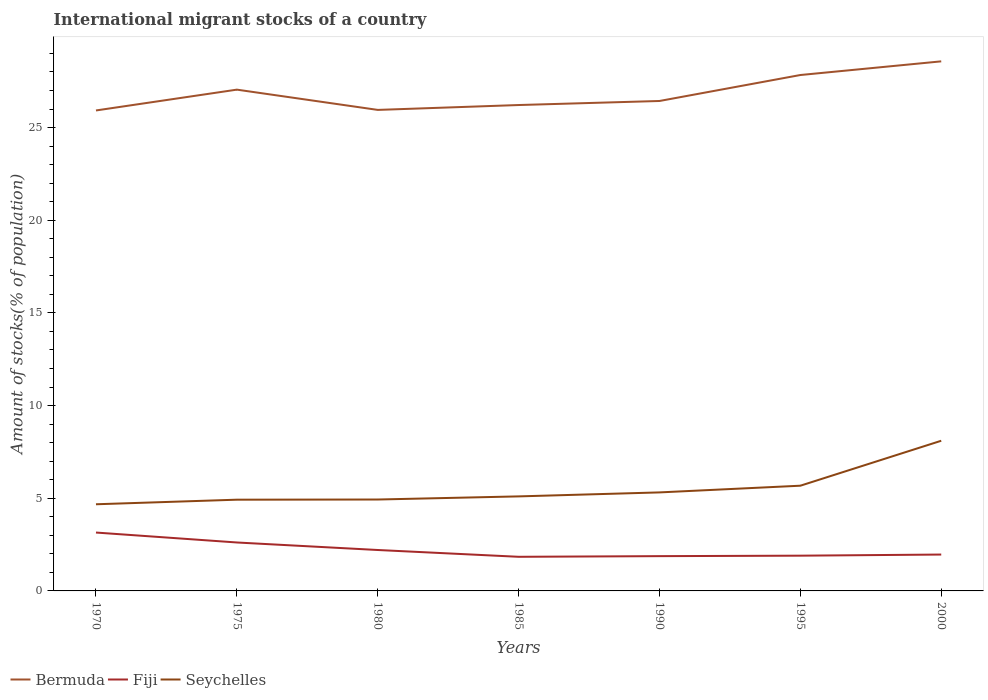How many different coloured lines are there?
Make the answer very short. 3. Is the number of lines equal to the number of legend labels?
Make the answer very short. Yes. Across all years, what is the maximum amount of stocks in in Bermuda?
Offer a very short reply. 25.92. In which year was the amount of stocks in in Fiji maximum?
Keep it short and to the point. 1985. What is the total amount of stocks in in Fiji in the graph?
Your answer should be very brief. 0.37. What is the difference between the highest and the second highest amount of stocks in in Seychelles?
Offer a terse response. 3.43. What is the difference between the highest and the lowest amount of stocks in in Seychelles?
Give a very brief answer. 2. How many years are there in the graph?
Make the answer very short. 7. What is the difference between two consecutive major ticks on the Y-axis?
Provide a short and direct response. 5. Where does the legend appear in the graph?
Your answer should be compact. Bottom left. What is the title of the graph?
Offer a very short reply. International migrant stocks of a country. Does "Latvia" appear as one of the legend labels in the graph?
Offer a very short reply. No. What is the label or title of the X-axis?
Give a very brief answer. Years. What is the label or title of the Y-axis?
Give a very brief answer. Amount of stocks(% of population). What is the Amount of stocks(% of population) in Bermuda in 1970?
Your answer should be very brief. 25.92. What is the Amount of stocks(% of population) of Fiji in 1970?
Offer a very short reply. 3.15. What is the Amount of stocks(% of population) of Seychelles in 1970?
Your answer should be compact. 4.68. What is the Amount of stocks(% of population) in Bermuda in 1975?
Your answer should be compact. 27.05. What is the Amount of stocks(% of population) in Fiji in 1975?
Offer a very short reply. 2.61. What is the Amount of stocks(% of population) in Seychelles in 1975?
Offer a very short reply. 4.92. What is the Amount of stocks(% of population) of Bermuda in 1980?
Make the answer very short. 25.95. What is the Amount of stocks(% of population) of Fiji in 1980?
Provide a succinct answer. 2.21. What is the Amount of stocks(% of population) in Seychelles in 1980?
Provide a succinct answer. 4.93. What is the Amount of stocks(% of population) in Bermuda in 1985?
Make the answer very short. 26.22. What is the Amount of stocks(% of population) of Fiji in 1985?
Provide a short and direct response. 1.84. What is the Amount of stocks(% of population) in Seychelles in 1985?
Your answer should be very brief. 5.1. What is the Amount of stocks(% of population) in Bermuda in 1990?
Offer a terse response. 26.44. What is the Amount of stocks(% of population) of Fiji in 1990?
Your response must be concise. 1.88. What is the Amount of stocks(% of population) in Seychelles in 1990?
Your answer should be compact. 5.32. What is the Amount of stocks(% of population) of Bermuda in 1995?
Offer a very short reply. 27.84. What is the Amount of stocks(% of population) in Fiji in 1995?
Provide a succinct answer. 1.9. What is the Amount of stocks(% of population) of Seychelles in 1995?
Provide a short and direct response. 5.68. What is the Amount of stocks(% of population) in Bermuda in 2000?
Provide a short and direct response. 28.57. What is the Amount of stocks(% of population) of Fiji in 2000?
Your answer should be compact. 1.96. What is the Amount of stocks(% of population) of Seychelles in 2000?
Ensure brevity in your answer.  8.1. Across all years, what is the maximum Amount of stocks(% of population) in Bermuda?
Offer a terse response. 28.57. Across all years, what is the maximum Amount of stocks(% of population) in Fiji?
Your response must be concise. 3.15. Across all years, what is the maximum Amount of stocks(% of population) of Seychelles?
Your answer should be very brief. 8.1. Across all years, what is the minimum Amount of stocks(% of population) in Bermuda?
Provide a short and direct response. 25.92. Across all years, what is the minimum Amount of stocks(% of population) of Fiji?
Ensure brevity in your answer.  1.84. Across all years, what is the minimum Amount of stocks(% of population) in Seychelles?
Make the answer very short. 4.68. What is the total Amount of stocks(% of population) of Bermuda in the graph?
Keep it short and to the point. 187.99. What is the total Amount of stocks(% of population) in Fiji in the graph?
Give a very brief answer. 15.55. What is the total Amount of stocks(% of population) in Seychelles in the graph?
Your response must be concise. 38.73. What is the difference between the Amount of stocks(% of population) of Bermuda in 1970 and that in 1975?
Keep it short and to the point. -1.12. What is the difference between the Amount of stocks(% of population) of Fiji in 1970 and that in 1975?
Keep it short and to the point. 0.54. What is the difference between the Amount of stocks(% of population) of Seychelles in 1970 and that in 1975?
Keep it short and to the point. -0.25. What is the difference between the Amount of stocks(% of population) in Bermuda in 1970 and that in 1980?
Keep it short and to the point. -0.03. What is the difference between the Amount of stocks(% of population) in Fiji in 1970 and that in 1980?
Provide a short and direct response. 0.94. What is the difference between the Amount of stocks(% of population) in Seychelles in 1970 and that in 1980?
Ensure brevity in your answer.  -0.26. What is the difference between the Amount of stocks(% of population) in Bermuda in 1970 and that in 1985?
Give a very brief answer. -0.29. What is the difference between the Amount of stocks(% of population) in Fiji in 1970 and that in 1985?
Provide a short and direct response. 1.31. What is the difference between the Amount of stocks(% of population) in Seychelles in 1970 and that in 1985?
Give a very brief answer. -0.43. What is the difference between the Amount of stocks(% of population) of Bermuda in 1970 and that in 1990?
Offer a terse response. -0.51. What is the difference between the Amount of stocks(% of population) of Fiji in 1970 and that in 1990?
Make the answer very short. 1.27. What is the difference between the Amount of stocks(% of population) in Seychelles in 1970 and that in 1990?
Your answer should be very brief. -0.64. What is the difference between the Amount of stocks(% of population) of Bermuda in 1970 and that in 1995?
Your answer should be compact. -1.91. What is the difference between the Amount of stocks(% of population) of Fiji in 1970 and that in 1995?
Offer a terse response. 1.25. What is the difference between the Amount of stocks(% of population) in Seychelles in 1970 and that in 1995?
Make the answer very short. -1. What is the difference between the Amount of stocks(% of population) of Bermuda in 1970 and that in 2000?
Keep it short and to the point. -2.65. What is the difference between the Amount of stocks(% of population) in Fiji in 1970 and that in 2000?
Your answer should be compact. 1.19. What is the difference between the Amount of stocks(% of population) of Seychelles in 1970 and that in 2000?
Keep it short and to the point. -3.43. What is the difference between the Amount of stocks(% of population) in Bermuda in 1975 and that in 1980?
Keep it short and to the point. 1.09. What is the difference between the Amount of stocks(% of population) in Fiji in 1975 and that in 1980?
Provide a succinct answer. 0.41. What is the difference between the Amount of stocks(% of population) of Seychelles in 1975 and that in 1980?
Your answer should be very brief. -0.01. What is the difference between the Amount of stocks(% of population) of Bermuda in 1975 and that in 1985?
Ensure brevity in your answer.  0.83. What is the difference between the Amount of stocks(% of population) in Fiji in 1975 and that in 1985?
Give a very brief answer. 0.77. What is the difference between the Amount of stocks(% of population) of Seychelles in 1975 and that in 1985?
Your response must be concise. -0.18. What is the difference between the Amount of stocks(% of population) in Bermuda in 1975 and that in 1990?
Offer a very short reply. 0.61. What is the difference between the Amount of stocks(% of population) in Fiji in 1975 and that in 1990?
Provide a succinct answer. 0.74. What is the difference between the Amount of stocks(% of population) of Seychelles in 1975 and that in 1990?
Ensure brevity in your answer.  -0.39. What is the difference between the Amount of stocks(% of population) of Bermuda in 1975 and that in 1995?
Your answer should be compact. -0.79. What is the difference between the Amount of stocks(% of population) of Fiji in 1975 and that in 1995?
Your response must be concise. 0.71. What is the difference between the Amount of stocks(% of population) in Seychelles in 1975 and that in 1995?
Offer a very short reply. -0.75. What is the difference between the Amount of stocks(% of population) of Bermuda in 1975 and that in 2000?
Ensure brevity in your answer.  -1.53. What is the difference between the Amount of stocks(% of population) in Fiji in 1975 and that in 2000?
Ensure brevity in your answer.  0.65. What is the difference between the Amount of stocks(% of population) in Seychelles in 1975 and that in 2000?
Keep it short and to the point. -3.18. What is the difference between the Amount of stocks(% of population) of Bermuda in 1980 and that in 1985?
Your answer should be compact. -0.26. What is the difference between the Amount of stocks(% of population) of Fiji in 1980 and that in 1985?
Give a very brief answer. 0.37. What is the difference between the Amount of stocks(% of population) of Seychelles in 1980 and that in 1985?
Give a very brief answer. -0.17. What is the difference between the Amount of stocks(% of population) of Bermuda in 1980 and that in 1990?
Your response must be concise. -0.48. What is the difference between the Amount of stocks(% of population) in Fiji in 1980 and that in 1990?
Offer a terse response. 0.33. What is the difference between the Amount of stocks(% of population) in Seychelles in 1980 and that in 1990?
Ensure brevity in your answer.  -0.38. What is the difference between the Amount of stocks(% of population) of Bermuda in 1980 and that in 1995?
Provide a short and direct response. -1.88. What is the difference between the Amount of stocks(% of population) in Fiji in 1980 and that in 1995?
Provide a short and direct response. 0.31. What is the difference between the Amount of stocks(% of population) of Seychelles in 1980 and that in 1995?
Offer a terse response. -0.75. What is the difference between the Amount of stocks(% of population) in Bermuda in 1980 and that in 2000?
Your response must be concise. -2.62. What is the difference between the Amount of stocks(% of population) in Fiji in 1980 and that in 2000?
Keep it short and to the point. 0.25. What is the difference between the Amount of stocks(% of population) of Seychelles in 1980 and that in 2000?
Ensure brevity in your answer.  -3.17. What is the difference between the Amount of stocks(% of population) in Bermuda in 1985 and that in 1990?
Make the answer very short. -0.22. What is the difference between the Amount of stocks(% of population) of Fiji in 1985 and that in 1990?
Give a very brief answer. -0.04. What is the difference between the Amount of stocks(% of population) in Seychelles in 1985 and that in 1990?
Ensure brevity in your answer.  -0.21. What is the difference between the Amount of stocks(% of population) of Bermuda in 1985 and that in 1995?
Provide a succinct answer. -1.62. What is the difference between the Amount of stocks(% of population) in Fiji in 1985 and that in 1995?
Provide a short and direct response. -0.06. What is the difference between the Amount of stocks(% of population) of Seychelles in 1985 and that in 1995?
Keep it short and to the point. -0.58. What is the difference between the Amount of stocks(% of population) in Bermuda in 1985 and that in 2000?
Provide a succinct answer. -2.36. What is the difference between the Amount of stocks(% of population) in Fiji in 1985 and that in 2000?
Offer a terse response. -0.12. What is the difference between the Amount of stocks(% of population) in Seychelles in 1985 and that in 2000?
Your answer should be very brief. -3. What is the difference between the Amount of stocks(% of population) in Bermuda in 1990 and that in 1995?
Your answer should be very brief. -1.4. What is the difference between the Amount of stocks(% of population) of Fiji in 1990 and that in 1995?
Ensure brevity in your answer.  -0.03. What is the difference between the Amount of stocks(% of population) in Seychelles in 1990 and that in 1995?
Make the answer very short. -0.36. What is the difference between the Amount of stocks(% of population) in Bermuda in 1990 and that in 2000?
Keep it short and to the point. -2.14. What is the difference between the Amount of stocks(% of population) in Fiji in 1990 and that in 2000?
Keep it short and to the point. -0.09. What is the difference between the Amount of stocks(% of population) of Seychelles in 1990 and that in 2000?
Your response must be concise. -2.79. What is the difference between the Amount of stocks(% of population) of Bermuda in 1995 and that in 2000?
Give a very brief answer. -0.74. What is the difference between the Amount of stocks(% of population) in Fiji in 1995 and that in 2000?
Make the answer very short. -0.06. What is the difference between the Amount of stocks(% of population) of Seychelles in 1995 and that in 2000?
Keep it short and to the point. -2.43. What is the difference between the Amount of stocks(% of population) of Bermuda in 1970 and the Amount of stocks(% of population) of Fiji in 1975?
Provide a succinct answer. 23.31. What is the difference between the Amount of stocks(% of population) in Bermuda in 1970 and the Amount of stocks(% of population) in Seychelles in 1975?
Provide a succinct answer. 21. What is the difference between the Amount of stocks(% of population) in Fiji in 1970 and the Amount of stocks(% of population) in Seychelles in 1975?
Offer a terse response. -1.77. What is the difference between the Amount of stocks(% of population) in Bermuda in 1970 and the Amount of stocks(% of population) in Fiji in 1980?
Offer a very short reply. 23.72. What is the difference between the Amount of stocks(% of population) of Bermuda in 1970 and the Amount of stocks(% of population) of Seychelles in 1980?
Your response must be concise. 20.99. What is the difference between the Amount of stocks(% of population) of Fiji in 1970 and the Amount of stocks(% of population) of Seychelles in 1980?
Your answer should be very brief. -1.78. What is the difference between the Amount of stocks(% of population) of Bermuda in 1970 and the Amount of stocks(% of population) of Fiji in 1985?
Your answer should be compact. 24.08. What is the difference between the Amount of stocks(% of population) of Bermuda in 1970 and the Amount of stocks(% of population) of Seychelles in 1985?
Make the answer very short. 20.82. What is the difference between the Amount of stocks(% of population) in Fiji in 1970 and the Amount of stocks(% of population) in Seychelles in 1985?
Provide a succinct answer. -1.95. What is the difference between the Amount of stocks(% of population) of Bermuda in 1970 and the Amount of stocks(% of population) of Fiji in 1990?
Keep it short and to the point. 24.05. What is the difference between the Amount of stocks(% of population) in Bermuda in 1970 and the Amount of stocks(% of population) in Seychelles in 1990?
Your answer should be very brief. 20.61. What is the difference between the Amount of stocks(% of population) in Fiji in 1970 and the Amount of stocks(% of population) in Seychelles in 1990?
Make the answer very short. -2.17. What is the difference between the Amount of stocks(% of population) in Bermuda in 1970 and the Amount of stocks(% of population) in Fiji in 1995?
Offer a terse response. 24.02. What is the difference between the Amount of stocks(% of population) in Bermuda in 1970 and the Amount of stocks(% of population) in Seychelles in 1995?
Offer a terse response. 20.25. What is the difference between the Amount of stocks(% of population) in Fiji in 1970 and the Amount of stocks(% of population) in Seychelles in 1995?
Provide a short and direct response. -2.53. What is the difference between the Amount of stocks(% of population) of Bermuda in 1970 and the Amount of stocks(% of population) of Fiji in 2000?
Offer a very short reply. 23.96. What is the difference between the Amount of stocks(% of population) in Bermuda in 1970 and the Amount of stocks(% of population) in Seychelles in 2000?
Your answer should be compact. 17.82. What is the difference between the Amount of stocks(% of population) of Fiji in 1970 and the Amount of stocks(% of population) of Seychelles in 2000?
Ensure brevity in your answer.  -4.95. What is the difference between the Amount of stocks(% of population) of Bermuda in 1975 and the Amount of stocks(% of population) of Fiji in 1980?
Your answer should be compact. 24.84. What is the difference between the Amount of stocks(% of population) of Bermuda in 1975 and the Amount of stocks(% of population) of Seychelles in 1980?
Ensure brevity in your answer.  22.12. What is the difference between the Amount of stocks(% of population) in Fiji in 1975 and the Amount of stocks(% of population) in Seychelles in 1980?
Your answer should be very brief. -2.32. What is the difference between the Amount of stocks(% of population) in Bermuda in 1975 and the Amount of stocks(% of population) in Fiji in 1985?
Provide a short and direct response. 25.21. What is the difference between the Amount of stocks(% of population) in Bermuda in 1975 and the Amount of stocks(% of population) in Seychelles in 1985?
Offer a very short reply. 21.95. What is the difference between the Amount of stocks(% of population) of Fiji in 1975 and the Amount of stocks(% of population) of Seychelles in 1985?
Your response must be concise. -2.49. What is the difference between the Amount of stocks(% of population) in Bermuda in 1975 and the Amount of stocks(% of population) in Fiji in 1990?
Provide a succinct answer. 25.17. What is the difference between the Amount of stocks(% of population) in Bermuda in 1975 and the Amount of stocks(% of population) in Seychelles in 1990?
Offer a very short reply. 21.73. What is the difference between the Amount of stocks(% of population) in Fiji in 1975 and the Amount of stocks(% of population) in Seychelles in 1990?
Provide a succinct answer. -2.7. What is the difference between the Amount of stocks(% of population) of Bermuda in 1975 and the Amount of stocks(% of population) of Fiji in 1995?
Your answer should be compact. 25.14. What is the difference between the Amount of stocks(% of population) in Bermuda in 1975 and the Amount of stocks(% of population) in Seychelles in 1995?
Your answer should be compact. 21.37. What is the difference between the Amount of stocks(% of population) of Fiji in 1975 and the Amount of stocks(% of population) of Seychelles in 1995?
Offer a very short reply. -3.06. What is the difference between the Amount of stocks(% of population) of Bermuda in 1975 and the Amount of stocks(% of population) of Fiji in 2000?
Offer a very short reply. 25.08. What is the difference between the Amount of stocks(% of population) of Bermuda in 1975 and the Amount of stocks(% of population) of Seychelles in 2000?
Give a very brief answer. 18.94. What is the difference between the Amount of stocks(% of population) of Fiji in 1975 and the Amount of stocks(% of population) of Seychelles in 2000?
Make the answer very short. -5.49. What is the difference between the Amount of stocks(% of population) of Bermuda in 1980 and the Amount of stocks(% of population) of Fiji in 1985?
Provide a succinct answer. 24.11. What is the difference between the Amount of stocks(% of population) in Bermuda in 1980 and the Amount of stocks(% of population) in Seychelles in 1985?
Ensure brevity in your answer.  20.85. What is the difference between the Amount of stocks(% of population) in Fiji in 1980 and the Amount of stocks(% of population) in Seychelles in 1985?
Offer a terse response. -2.89. What is the difference between the Amount of stocks(% of population) in Bermuda in 1980 and the Amount of stocks(% of population) in Fiji in 1990?
Provide a short and direct response. 24.08. What is the difference between the Amount of stocks(% of population) of Bermuda in 1980 and the Amount of stocks(% of population) of Seychelles in 1990?
Keep it short and to the point. 20.64. What is the difference between the Amount of stocks(% of population) in Fiji in 1980 and the Amount of stocks(% of population) in Seychelles in 1990?
Offer a very short reply. -3.11. What is the difference between the Amount of stocks(% of population) of Bermuda in 1980 and the Amount of stocks(% of population) of Fiji in 1995?
Your answer should be very brief. 24.05. What is the difference between the Amount of stocks(% of population) in Bermuda in 1980 and the Amount of stocks(% of population) in Seychelles in 1995?
Your answer should be very brief. 20.28. What is the difference between the Amount of stocks(% of population) in Fiji in 1980 and the Amount of stocks(% of population) in Seychelles in 1995?
Offer a terse response. -3.47. What is the difference between the Amount of stocks(% of population) in Bermuda in 1980 and the Amount of stocks(% of population) in Fiji in 2000?
Your answer should be very brief. 23.99. What is the difference between the Amount of stocks(% of population) of Bermuda in 1980 and the Amount of stocks(% of population) of Seychelles in 2000?
Keep it short and to the point. 17.85. What is the difference between the Amount of stocks(% of population) in Fiji in 1980 and the Amount of stocks(% of population) in Seychelles in 2000?
Your answer should be compact. -5.9. What is the difference between the Amount of stocks(% of population) of Bermuda in 1985 and the Amount of stocks(% of population) of Fiji in 1990?
Your answer should be compact. 24.34. What is the difference between the Amount of stocks(% of population) of Bermuda in 1985 and the Amount of stocks(% of population) of Seychelles in 1990?
Offer a very short reply. 20.9. What is the difference between the Amount of stocks(% of population) of Fiji in 1985 and the Amount of stocks(% of population) of Seychelles in 1990?
Make the answer very short. -3.47. What is the difference between the Amount of stocks(% of population) in Bermuda in 1985 and the Amount of stocks(% of population) in Fiji in 1995?
Ensure brevity in your answer.  24.31. What is the difference between the Amount of stocks(% of population) in Bermuda in 1985 and the Amount of stocks(% of population) in Seychelles in 1995?
Your answer should be compact. 20.54. What is the difference between the Amount of stocks(% of population) in Fiji in 1985 and the Amount of stocks(% of population) in Seychelles in 1995?
Give a very brief answer. -3.84. What is the difference between the Amount of stocks(% of population) in Bermuda in 1985 and the Amount of stocks(% of population) in Fiji in 2000?
Offer a very short reply. 24.25. What is the difference between the Amount of stocks(% of population) of Bermuda in 1985 and the Amount of stocks(% of population) of Seychelles in 2000?
Ensure brevity in your answer.  18.11. What is the difference between the Amount of stocks(% of population) in Fiji in 1985 and the Amount of stocks(% of population) in Seychelles in 2000?
Your response must be concise. -6.26. What is the difference between the Amount of stocks(% of population) in Bermuda in 1990 and the Amount of stocks(% of population) in Fiji in 1995?
Give a very brief answer. 24.53. What is the difference between the Amount of stocks(% of population) in Bermuda in 1990 and the Amount of stocks(% of population) in Seychelles in 1995?
Keep it short and to the point. 20.76. What is the difference between the Amount of stocks(% of population) in Fiji in 1990 and the Amount of stocks(% of population) in Seychelles in 1995?
Make the answer very short. -3.8. What is the difference between the Amount of stocks(% of population) in Bermuda in 1990 and the Amount of stocks(% of population) in Fiji in 2000?
Provide a short and direct response. 24.47. What is the difference between the Amount of stocks(% of population) of Bermuda in 1990 and the Amount of stocks(% of population) of Seychelles in 2000?
Your answer should be compact. 18.33. What is the difference between the Amount of stocks(% of population) of Fiji in 1990 and the Amount of stocks(% of population) of Seychelles in 2000?
Offer a terse response. -6.23. What is the difference between the Amount of stocks(% of population) of Bermuda in 1995 and the Amount of stocks(% of population) of Fiji in 2000?
Provide a succinct answer. 25.87. What is the difference between the Amount of stocks(% of population) in Bermuda in 1995 and the Amount of stocks(% of population) in Seychelles in 2000?
Ensure brevity in your answer.  19.73. What is the difference between the Amount of stocks(% of population) of Fiji in 1995 and the Amount of stocks(% of population) of Seychelles in 2000?
Your answer should be compact. -6.2. What is the average Amount of stocks(% of population) of Bermuda per year?
Provide a short and direct response. 26.86. What is the average Amount of stocks(% of population) of Fiji per year?
Make the answer very short. 2.22. What is the average Amount of stocks(% of population) of Seychelles per year?
Offer a terse response. 5.53. In the year 1970, what is the difference between the Amount of stocks(% of population) in Bermuda and Amount of stocks(% of population) in Fiji?
Offer a terse response. 22.77. In the year 1970, what is the difference between the Amount of stocks(% of population) of Bermuda and Amount of stocks(% of population) of Seychelles?
Provide a succinct answer. 21.25. In the year 1970, what is the difference between the Amount of stocks(% of population) in Fiji and Amount of stocks(% of population) in Seychelles?
Give a very brief answer. -1.53. In the year 1975, what is the difference between the Amount of stocks(% of population) of Bermuda and Amount of stocks(% of population) of Fiji?
Make the answer very short. 24.43. In the year 1975, what is the difference between the Amount of stocks(% of population) in Bermuda and Amount of stocks(% of population) in Seychelles?
Offer a very short reply. 22.12. In the year 1975, what is the difference between the Amount of stocks(% of population) of Fiji and Amount of stocks(% of population) of Seychelles?
Provide a short and direct response. -2.31. In the year 1980, what is the difference between the Amount of stocks(% of population) in Bermuda and Amount of stocks(% of population) in Fiji?
Make the answer very short. 23.75. In the year 1980, what is the difference between the Amount of stocks(% of population) in Bermuda and Amount of stocks(% of population) in Seychelles?
Give a very brief answer. 21.02. In the year 1980, what is the difference between the Amount of stocks(% of population) in Fiji and Amount of stocks(% of population) in Seychelles?
Provide a succinct answer. -2.72. In the year 1985, what is the difference between the Amount of stocks(% of population) of Bermuda and Amount of stocks(% of population) of Fiji?
Your response must be concise. 24.38. In the year 1985, what is the difference between the Amount of stocks(% of population) of Bermuda and Amount of stocks(% of population) of Seychelles?
Ensure brevity in your answer.  21.12. In the year 1985, what is the difference between the Amount of stocks(% of population) in Fiji and Amount of stocks(% of population) in Seychelles?
Provide a short and direct response. -3.26. In the year 1990, what is the difference between the Amount of stocks(% of population) of Bermuda and Amount of stocks(% of population) of Fiji?
Provide a succinct answer. 24.56. In the year 1990, what is the difference between the Amount of stocks(% of population) of Bermuda and Amount of stocks(% of population) of Seychelles?
Offer a very short reply. 21.12. In the year 1990, what is the difference between the Amount of stocks(% of population) of Fiji and Amount of stocks(% of population) of Seychelles?
Ensure brevity in your answer.  -3.44. In the year 1995, what is the difference between the Amount of stocks(% of population) of Bermuda and Amount of stocks(% of population) of Fiji?
Your answer should be compact. 25.93. In the year 1995, what is the difference between the Amount of stocks(% of population) in Bermuda and Amount of stocks(% of population) in Seychelles?
Give a very brief answer. 22.16. In the year 1995, what is the difference between the Amount of stocks(% of population) of Fiji and Amount of stocks(% of population) of Seychelles?
Keep it short and to the point. -3.77. In the year 2000, what is the difference between the Amount of stocks(% of population) in Bermuda and Amount of stocks(% of population) in Fiji?
Ensure brevity in your answer.  26.61. In the year 2000, what is the difference between the Amount of stocks(% of population) of Bermuda and Amount of stocks(% of population) of Seychelles?
Your answer should be very brief. 20.47. In the year 2000, what is the difference between the Amount of stocks(% of population) of Fiji and Amount of stocks(% of population) of Seychelles?
Provide a succinct answer. -6.14. What is the ratio of the Amount of stocks(% of population) of Bermuda in 1970 to that in 1975?
Provide a short and direct response. 0.96. What is the ratio of the Amount of stocks(% of population) of Fiji in 1970 to that in 1975?
Offer a very short reply. 1.2. What is the ratio of the Amount of stocks(% of population) of Seychelles in 1970 to that in 1975?
Your answer should be compact. 0.95. What is the ratio of the Amount of stocks(% of population) of Fiji in 1970 to that in 1980?
Your response must be concise. 1.43. What is the ratio of the Amount of stocks(% of population) of Seychelles in 1970 to that in 1980?
Your answer should be very brief. 0.95. What is the ratio of the Amount of stocks(% of population) of Fiji in 1970 to that in 1985?
Your answer should be compact. 1.71. What is the ratio of the Amount of stocks(% of population) in Seychelles in 1970 to that in 1985?
Your answer should be very brief. 0.92. What is the ratio of the Amount of stocks(% of population) in Bermuda in 1970 to that in 1990?
Ensure brevity in your answer.  0.98. What is the ratio of the Amount of stocks(% of population) of Fiji in 1970 to that in 1990?
Offer a terse response. 1.68. What is the ratio of the Amount of stocks(% of population) in Seychelles in 1970 to that in 1990?
Ensure brevity in your answer.  0.88. What is the ratio of the Amount of stocks(% of population) in Bermuda in 1970 to that in 1995?
Your answer should be compact. 0.93. What is the ratio of the Amount of stocks(% of population) in Fiji in 1970 to that in 1995?
Make the answer very short. 1.66. What is the ratio of the Amount of stocks(% of population) in Seychelles in 1970 to that in 1995?
Give a very brief answer. 0.82. What is the ratio of the Amount of stocks(% of population) of Bermuda in 1970 to that in 2000?
Provide a succinct answer. 0.91. What is the ratio of the Amount of stocks(% of population) in Fiji in 1970 to that in 2000?
Provide a succinct answer. 1.61. What is the ratio of the Amount of stocks(% of population) in Seychelles in 1970 to that in 2000?
Offer a terse response. 0.58. What is the ratio of the Amount of stocks(% of population) of Bermuda in 1975 to that in 1980?
Your answer should be very brief. 1.04. What is the ratio of the Amount of stocks(% of population) of Fiji in 1975 to that in 1980?
Give a very brief answer. 1.18. What is the ratio of the Amount of stocks(% of population) of Bermuda in 1975 to that in 1985?
Your response must be concise. 1.03. What is the ratio of the Amount of stocks(% of population) of Fiji in 1975 to that in 1985?
Offer a terse response. 1.42. What is the ratio of the Amount of stocks(% of population) in Seychelles in 1975 to that in 1985?
Make the answer very short. 0.97. What is the ratio of the Amount of stocks(% of population) in Bermuda in 1975 to that in 1990?
Offer a terse response. 1.02. What is the ratio of the Amount of stocks(% of population) in Fiji in 1975 to that in 1990?
Make the answer very short. 1.39. What is the ratio of the Amount of stocks(% of population) of Seychelles in 1975 to that in 1990?
Offer a terse response. 0.93. What is the ratio of the Amount of stocks(% of population) in Bermuda in 1975 to that in 1995?
Your answer should be compact. 0.97. What is the ratio of the Amount of stocks(% of population) of Fiji in 1975 to that in 1995?
Make the answer very short. 1.37. What is the ratio of the Amount of stocks(% of population) in Seychelles in 1975 to that in 1995?
Make the answer very short. 0.87. What is the ratio of the Amount of stocks(% of population) in Bermuda in 1975 to that in 2000?
Give a very brief answer. 0.95. What is the ratio of the Amount of stocks(% of population) in Fiji in 1975 to that in 2000?
Offer a terse response. 1.33. What is the ratio of the Amount of stocks(% of population) of Seychelles in 1975 to that in 2000?
Make the answer very short. 0.61. What is the ratio of the Amount of stocks(% of population) in Bermuda in 1980 to that in 1985?
Provide a short and direct response. 0.99. What is the ratio of the Amount of stocks(% of population) of Fiji in 1980 to that in 1985?
Your response must be concise. 1.2. What is the ratio of the Amount of stocks(% of population) of Seychelles in 1980 to that in 1985?
Your answer should be very brief. 0.97. What is the ratio of the Amount of stocks(% of population) of Bermuda in 1980 to that in 1990?
Provide a short and direct response. 0.98. What is the ratio of the Amount of stocks(% of population) of Fiji in 1980 to that in 1990?
Offer a terse response. 1.18. What is the ratio of the Amount of stocks(% of population) of Seychelles in 1980 to that in 1990?
Offer a terse response. 0.93. What is the ratio of the Amount of stocks(% of population) of Bermuda in 1980 to that in 1995?
Your answer should be very brief. 0.93. What is the ratio of the Amount of stocks(% of population) of Fiji in 1980 to that in 1995?
Your response must be concise. 1.16. What is the ratio of the Amount of stocks(% of population) of Seychelles in 1980 to that in 1995?
Keep it short and to the point. 0.87. What is the ratio of the Amount of stocks(% of population) in Bermuda in 1980 to that in 2000?
Ensure brevity in your answer.  0.91. What is the ratio of the Amount of stocks(% of population) of Fiji in 1980 to that in 2000?
Keep it short and to the point. 1.13. What is the ratio of the Amount of stocks(% of population) of Seychelles in 1980 to that in 2000?
Offer a very short reply. 0.61. What is the ratio of the Amount of stocks(% of population) in Fiji in 1985 to that in 1990?
Offer a very short reply. 0.98. What is the ratio of the Amount of stocks(% of population) in Seychelles in 1985 to that in 1990?
Make the answer very short. 0.96. What is the ratio of the Amount of stocks(% of population) of Bermuda in 1985 to that in 1995?
Your answer should be compact. 0.94. What is the ratio of the Amount of stocks(% of population) of Fiji in 1985 to that in 1995?
Keep it short and to the point. 0.97. What is the ratio of the Amount of stocks(% of population) of Seychelles in 1985 to that in 1995?
Offer a very short reply. 0.9. What is the ratio of the Amount of stocks(% of population) of Bermuda in 1985 to that in 2000?
Your answer should be compact. 0.92. What is the ratio of the Amount of stocks(% of population) of Fiji in 1985 to that in 2000?
Provide a short and direct response. 0.94. What is the ratio of the Amount of stocks(% of population) of Seychelles in 1985 to that in 2000?
Your answer should be compact. 0.63. What is the ratio of the Amount of stocks(% of population) of Bermuda in 1990 to that in 1995?
Offer a very short reply. 0.95. What is the ratio of the Amount of stocks(% of population) in Fiji in 1990 to that in 1995?
Provide a short and direct response. 0.99. What is the ratio of the Amount of stocks(% of population) of Seychelles in 1990 to that in 1995?
Provide a succinct answer. 0.94. What is the ratio of the Amount of stocks(% of population) of Bermuda in 1990 to that in 2000?
Your answer should be compact. 0.93. What is the ratio of the Amount of stocks(% of population) in Fiji in 1990 to that in 2000?
Provide a succinct answer. 0.96. What is the ratio of the Amount of stocks(% of population) of Seychelles in 1990 to that in 2000?
Keep it short and to the point. 0.66. What is the ratio of the Amount of stocks(% of population) in Bermuda in 1995 to that in 2000?
Your response must be concise. 0.97. What is the ratio of the Amount of stocks(% of population) of Fiji in 1995 to that in 2000?
Your answer should be compact. 0.97. What is the ratio of the Amount of stocks(% of population) in Seychelles in 1995 to that in 2000?
Provide a succinct answer. 0.7. What is the difference between the highest and the second highest Amount of stocks(% of population) in Bermuda?
Make the answer very short. 0.74. What is the difference between the highest and the second highest Amount of stocks(% of population) of Fiji?
Give a very brief answer. 0.54. What is the difference between the highest and the second highest Amount of stocks(% of population) in Seychelles?
Provide a succinct answer. 2.43. What is the difference between the highest and the lowest Amount of stocks(% of population) of Bermuda?
Provide a short and direct response. 2.65. What is the difference between the highest and the lowest Amount of stocks(% of population) in Fiji?
Ensure brevity in your answer.  1.31. What is the difference between the highest and the lowest Amount of stocks(% of population) of Seychelles?
Give a very brief answer. 3.43. 